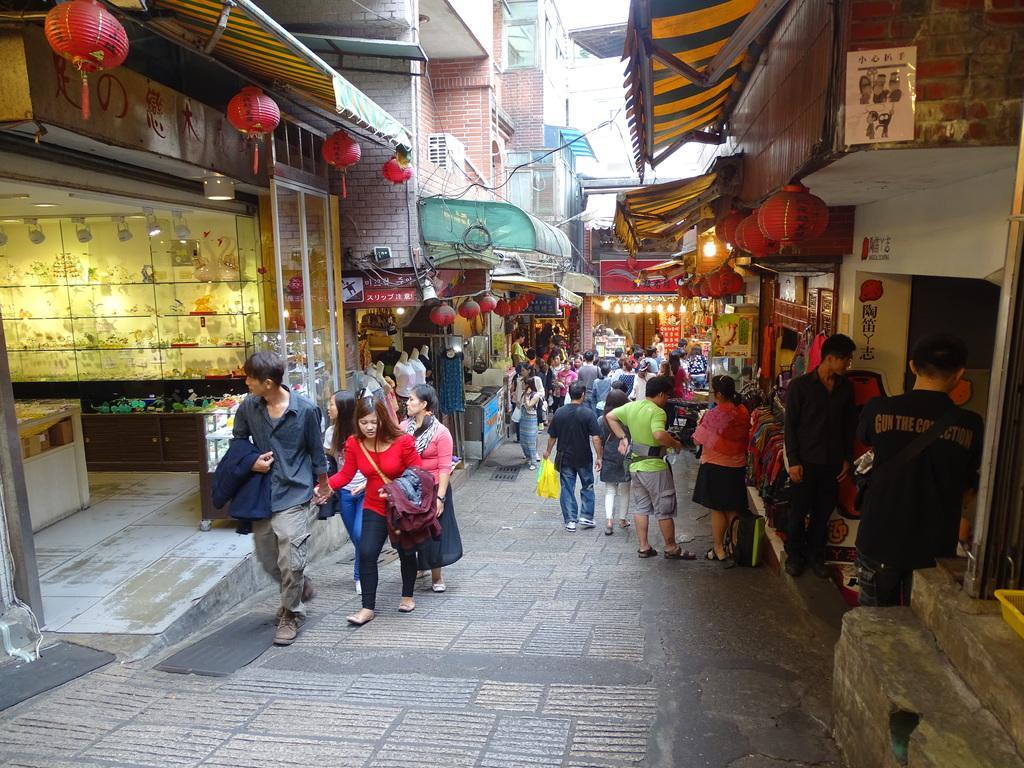Please provide a concise description of this image. In this image there are a few people walking on the streets, beside the streets there are shops. In front of the shops there are cloth rooftops, lamps and name boards. In the shops there are some objects. 